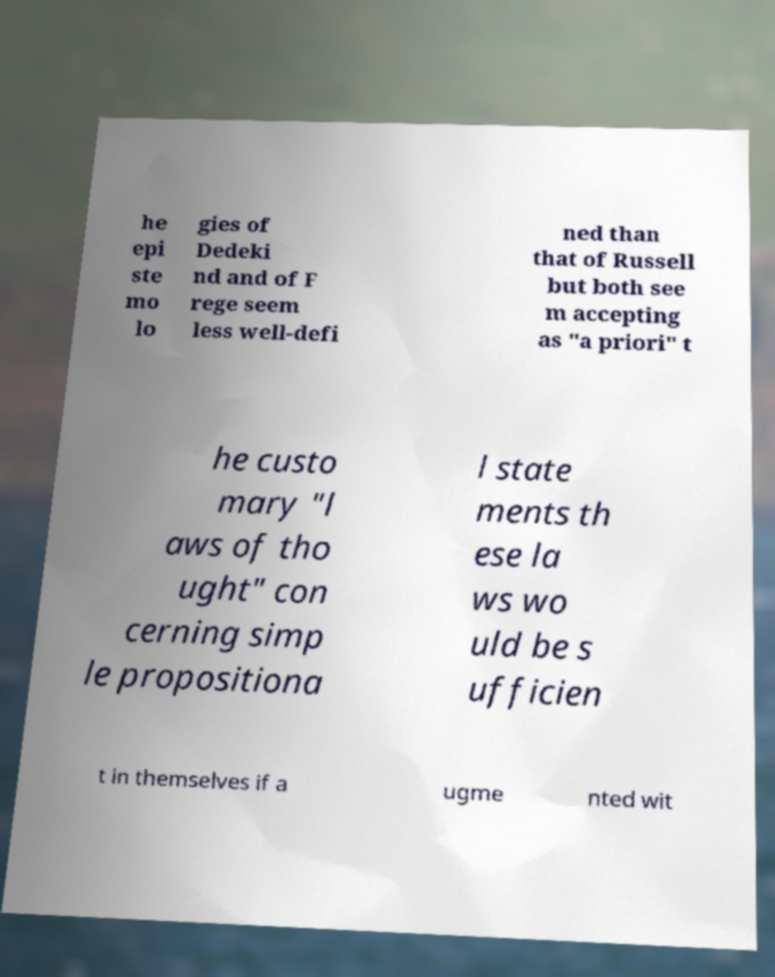Could you assist in decoding the text presented in this image and type it out clearly? he epi ste mo lo gies of Dedeki nd and of F rege seem less well-defi ned than that of Russell but both see m accepting as "a priori" t he custo mary "l aws of tho ught" con cerning simp le propositiona l state ments th ese la ws wo uld be s ufficien t in themselves if a ugme nted wit 